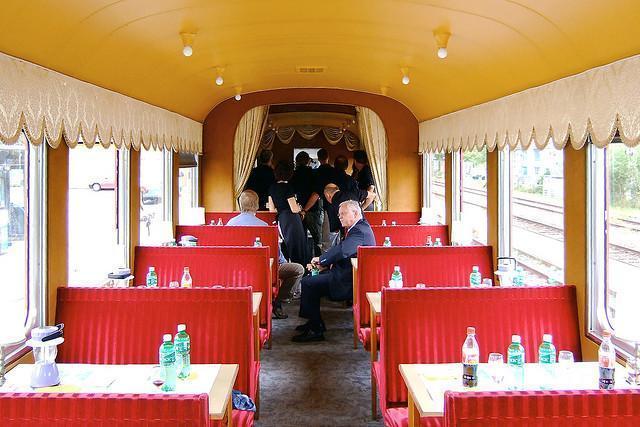How many bottles are in the front, left table?
Give a very brief answer. 2. How many dining tables are there?
Give a very brief answer. 2. How many people are visible?
Give a very brief answer. 3. How many benches are there?
Give a very brief answer. 8. 